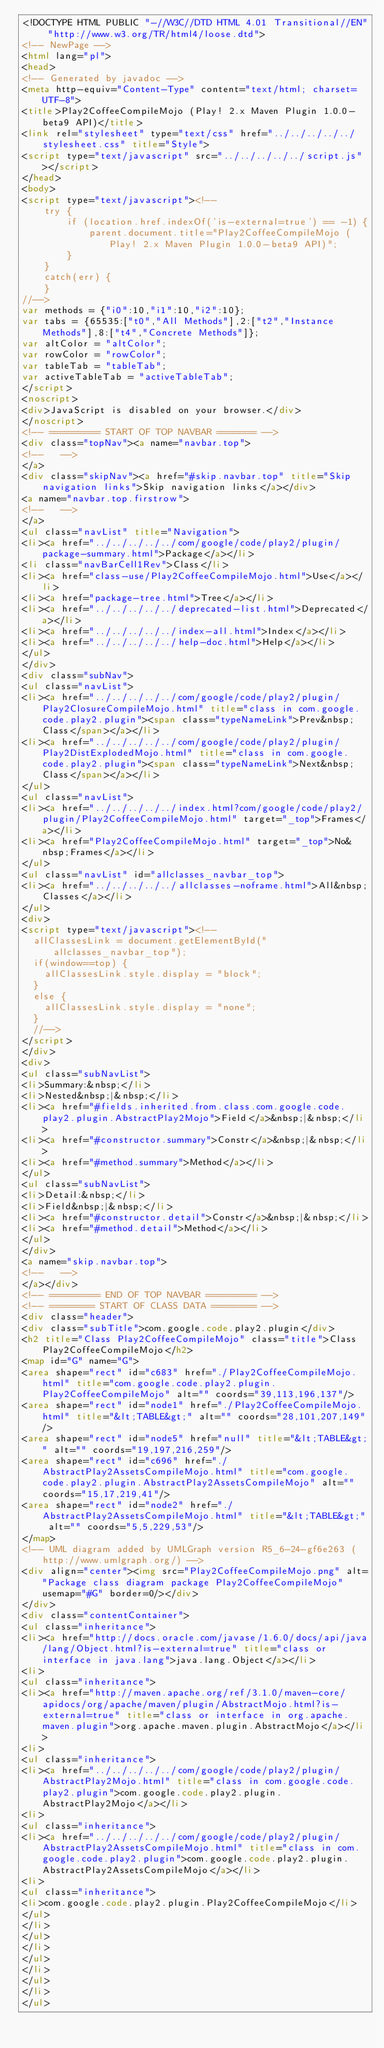<code> <loc_0><loc_0><loc_500><loc_500><_HTML_><!DOCTYPE HTML PUBLIC "-//W3C//DTD HTML 4.01 Transitional//EN" "http://www.w3.org/TR/html4/loose.dtd">
<!-- NewPage -->
<html lang="pl">
<head>
<!-- Generated by javadoc -->
<meta http-equiv="Content-Type" content="text/html; charset=UTF-8">
<title>Play2CoffeeCompileMojo (Play! 2.x Maven Plugin 1.0.0-beta9 API)</title>
<link rel="stylesheet" type="text/css" href="../../../../../stylesheet.css" title="Style">
<script type="text/javascript" src="../../../../../script.js"></script>
</head>
<body>
<script type="text/javascript"><!--
    try {
        if (location.href.indexOf('is-external=true') == -1) {
            parent.document.title="Play2CoffeeCompileMojo (Play! 2.x Maven Plugin 1.0.0-beta9 API)";
        }
    }
    catch(err) {
    }
//-->
var methods = {"i0":10,"i1":10,"i2":10};
var tabs = {65535:["t0","All Methods"],2:["t2","Instance Methods"],8:["t4","Concrete Methods"]};
var altColor = "altColor";
var rowColor = "rowColor";
var tableTab = "tableTab";
var activeTableTab = "activeTableTab";
</script>
<noscript>
<div>JavaScript is disabled on your browser.</div>
</noscript>
<!-- ========= START OF TOP NAVBAR ======= -->
<div class="topNav"><a name="navbar.top">
<!--   -->
</a>
<div class="skipNav"><a href="#skip.navbar.top" title="Skip navigation links">Skip navigation links</a></div>
<a name="navbar.top.firstrow">
<!--   -->
</a>
<ul class="navList" title="Navigation">
<li><a href="../../../../../com/google/code/play2/plugin/package-summary.html">Package</a></li>
<li class="navBarCell1Rev">Class</li>
<li><a href="class-use/Play2CoffeeCompileMojo.html">Use</a></li>
<li><a href="package-tree.html">Tree</a></li>
<li><a href="../../../../../deprecated-list.html">Deprecated</a></li>
<li><a href="../../../../../index-all.html">Index</a></li>
<li><a href="../../../../../help-doc.html">Help</a></li>
</ul>
</div>
<div class="subNav">
<ul class="navList">
<li><a href="../../../../../com/google/code/play2/plugin/Play2ClosureCompileMojo.html" title="class in com.google.code.play2.plugin"><span class="typeNameLink">Prev&nbsp;Class</span></a></li>
<li><a href="../../../../../com/google/code/play2/plugin/Play2DistExplodedMojo.html" title="class in com.google.code.play2.plugin"><span class="typeNameLink">Next&nbsp;Class</span></a></li>
</ul>
<ul class="navList">
<li><a href="../../../../../index.html?com/google/code/play2/plugin/Play2CoffeeCompileMojo.html" target="_top">Frames</a></li>
<li><a href="Play2CoffeeCompileMojo.html" target="_top">No&nbsp;Frames</a></li>
</ul>
<ul class="navList" id="allclasses_navbar_top">
<li><a href="../../../../../allclasses-noframe.html">All&nbsp;Classes</a></li>
</ul>
<div>
<script type="text/javascript"><!--
  allClassesLink = document.getElementById("allclasses_navbar_top");
  if(window==top) {
    allClassesLink.style.display = "block";
  }
  else {
    allClassesLink.style.display = "none";
  }
  //-->
</script>
</div>
<div>
<ul class="subNavList">
<li>Summary:&nbsp;</li>
<li>Nested&nbsp;|&nbsp;</li>
<li><a href="#fields.inherited.from.class.com.google.code.play2.plugin.AbstractPlay2Mojo">Field</a>&nbsp;|&nbsp;</li>
<li><a href="#constructor.summary">Constr</a>&nbsp;|&nbsp;</li>
<li><a href="#method.summary">Method</a></li>
</ul>
<ul class="subNavList">
<li>Detail:&nbsp;</li>
<li>Field&nbsp;|&nbsp;</li>
<li><a href="#constructor.detail">Constr</a>&nbsp;|&nbsp;</li>
<li><a href="#method.detail">Method</a></li>
</ul>
</div>
<a name="skip.navbar.top">
<!--   -->
</a></div>
<!-- ========= END OF TOP NAVBAR ========= -->
<!-- ======== START OF CLASS DATA ======== -->
<div class="header">
<div class="subTitle">com.google.code.play2.plugin</div>
<h2 title="Class Play2CoffeeCompileMojo" class="title">Class Play2CoffeeCompileMojo</h2>
<map id="G" name="G">
<area shape="rect" id="c683" href="./Play2CoffeeCompileMojo.html" title="com.google.code.play2.plugin.Play2CoffeeCompileMojo" alt="" coords="39,113,196,137"/>
<area shape="rect" id="node1" href="./Play2CoffeeCompileMojo.html" title="&lt;TABLE&gt;" alt="" coords="28,101,207,149"/>
<area shape="rect" id="node5" href="null" title="&lt;TABLE&gt;" alt="" coords="19,197,216,259"/>
<area shape="rect" id="c696" href="./AbstractPlay2AssetsCompileMojo.html" title="com.google.code.play2.plugin.AbstractPlay2AssetsCompileMojo" alt="" coords="15,17,219,41"/>
<area shape="rect" id="node2" href="./AbstractPlay2AssetsCompileMojo.html" title="&lt;TABLE&gt;" alt="" coords="5,5,229,53"/>
</map>
<!-- UML diagram added by UMLGraph version R5_6-24-gf6e263 (http://www.umlgraph.org/) -->
<div align="center"><img src="Play2CoffeeCompileMojo.png" alt="Package class diagram package Play2CoffeeCompileMojo" usemap="#G" border=0/></div>
</div>
<div class="contentContainer">
<ul class="inheritance">
<li><a href="http://docs.oracle.com/javase/1.6.0/docs/api/java/lang/Object.html?is-external=true" title="class or interface in java.lang">java.lang.Object</a></li>
<li>
<ul class="inheritance">
<li><a href="http://maven.apache.org/ref/3.1.0/maven-core/apidocs/org/apache/maven/plugin/AbstractMojo.html?is-external=true" title="class or interface in org.apache.maven.plugin">org.apache.maven.plugin.AbstractMojo</a></li>
<li>
<ul class="inheritance">
<li><a href="../../../../../com/google/code/play2/plugin/AbstractPlay2Mojo.html" title="class in com.google.code.play2.plugin">com.google.code.play2.plugin.AbstractPlay2Mojo</a></li>
<li>
<ul class="inheritance">
<li><a href="../../../../../com/google/code/play2/plugin/AbstractPlay2AssetsCompileMojo.html" title="class in com.google.code.play2.plugin">com.google.code.play2.plugin.AbstractPlay2AssetsCompileMojo</a></li>
<li>
<ul class="inheritance">
<li>com.google.code.play2.plugin.Play2CoffeeCompileMojo</li>
</ul>
</li>
</ul>
</li>
</ul>
</li>
</ul>
</li>
</ul></code> 